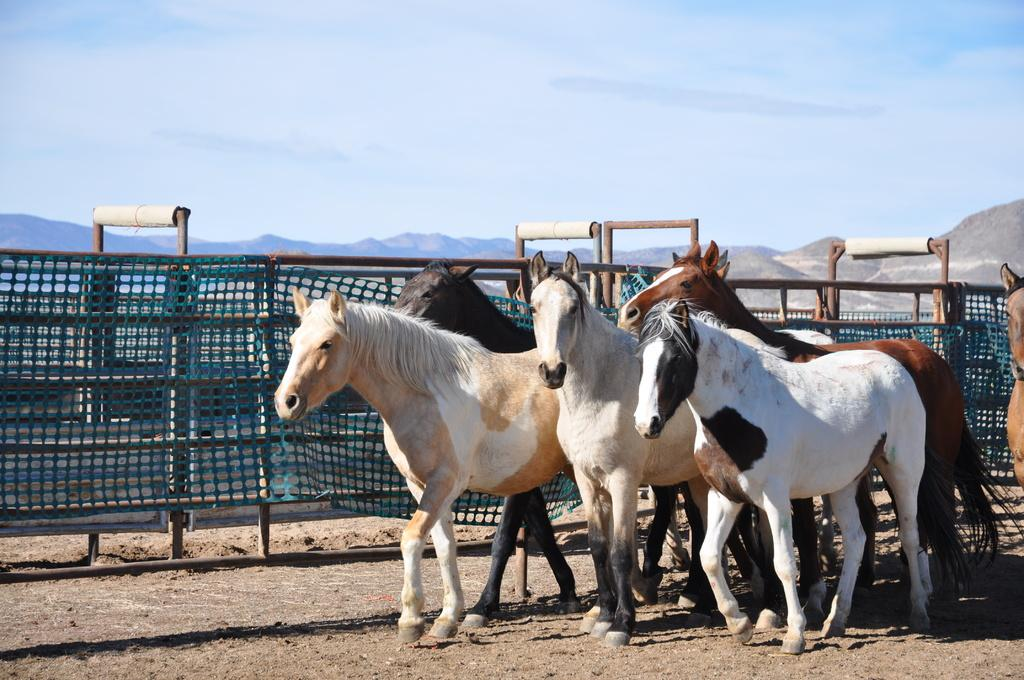What animals are present in the image? There is a group of horses in the image. Where are the horses located in the image? The horses are at the bottom right of the image. What can be observed about the horses' appearance? The horses are in different colors. What is behind the horses in the image? There is a fence behind the horses. What can be seen in the distance in the image? There are hills visible in the background of the image. What is visible above the hills in the image? The sky is visible in the background of the image. What type of toys can be seen scattered around the horses in the image? There are no toys present in the image; it features a group of horses with a fence and hills in the background. 